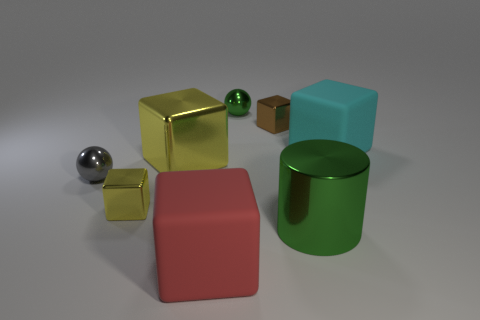Subtract all yellow balls. How many yellow blocks are left? 2 Subtract all large yellow metallic blocks. How many blocks are left? 4 Add 1 large purple matte cylinders. How many objects exist? 9 Subtract all yellow cubes. How many cubes are left? 3 Subtract all spheres. How many objects are left? 6 Subtract all gray blocks. Subtract all gray cylinders. How many blocks are left? 5 Subtract all small green shiny balls. Subtract all green objects. How many objects are left? 5 Add 5 yellow metal objects. How many yellow metal objects are left? 7 Add 3 red objects. How many red objects exist? 4 Subtract 1 green cylinders. How many objects are left? 7 